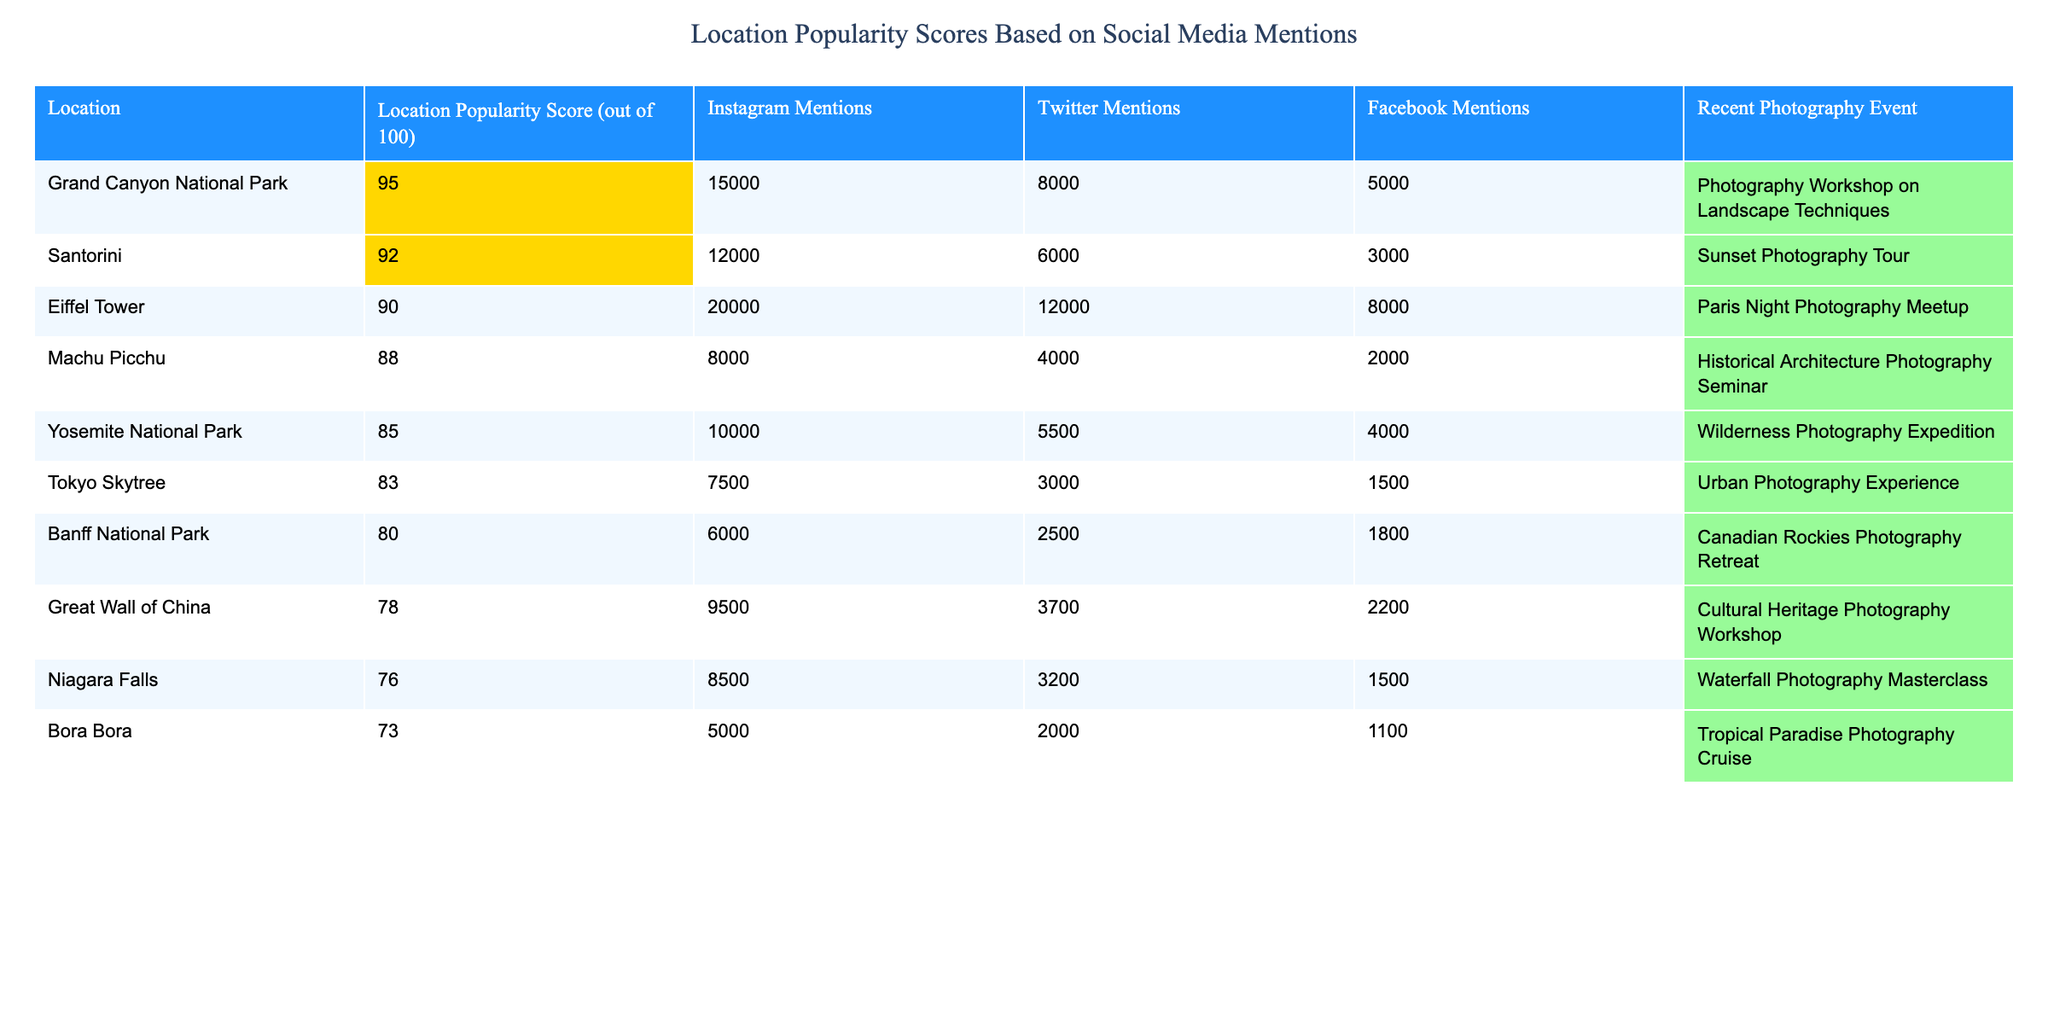What is the location with the highest popularity score? The location with the highest popularity score is Grand Canyon National Park with a score of 95.
Answer: Grand Canyon National Park How many total Instagram mentions does Santorini and Bora Bora have combined? Santorini has 12,000 Instagram mentions, and Bora Bora has 5,000. Adding these gives 12,000 + 5,000 = 17,000 total Instagram mentions combined.
Answer: 17,000 Which location has a recent photography event focused on architecture? Machu Picchu has a recent photography event titled "Historical Architecture Photography Seminar".
Answer: Machu Picchu Is the Great Wall of China more popular than Niagara Falls based on social media mentions? The Great Wall of China has a popularity score of 78 while Niagara Falls has a score of 76, indicating the Great Wall of China is more popular.
Answer: Yes What is the average popularity score of the locations listed? The scores are 95, 92, 90, 88, 85, 83, 80, 78, 76, and 73. The sum is  95 + 92 + 90 + 88 + 85 + 83 + 80 + 78 + 76 + 73 =  919. Dividing this by 10 locations gives an average of 919 / 10 = 91.9.
Answer: 91.9 Which photography event is associated with the lowest popularity score? Bora Bora has the lowest popularity score of 73, and its associated event is "Tropical Paradise Photography Cruise."
Answer: Tropical Paradise Photography Cruise Are there more mentions on Twitter for the Eiffel Tower or Yosemite National Park? The Eiffel Tower has 12,000 Twitter mentions, while Yosemite National Park has 5,500. Since 12,000 > 5,500, the Eiffel Tower has more mentions on Twitter.
Answer: Eiffel Tower Which location has the most mentions on Facebook? The Eiffel Tower has 8,000 mentions on Facebook, which is more than any other location listed.
Answer: Eiffel Tower If you combined the Instagram and Twitter mentions for Banff National Park, what would that total be? Banff National Park has 6,000 Instagram mentions and 2,500 Twitter mentions. The total is 6,000 + 2,500 = 8,500.
Answer: 8,500 Is there a location that has a photography event which doesn't include the word "Photography" in its title? Each listed recent photography event includes the word "Photography" in the title; therefore, there is no such location.
Answer: No Which two locations have the closest popularity scores? Both Banff National Park (80) and Great Wall of China (78) have scores that are relatively close with a difference of only 2 points.
Answer: Banff National Park and Great Wall of China 